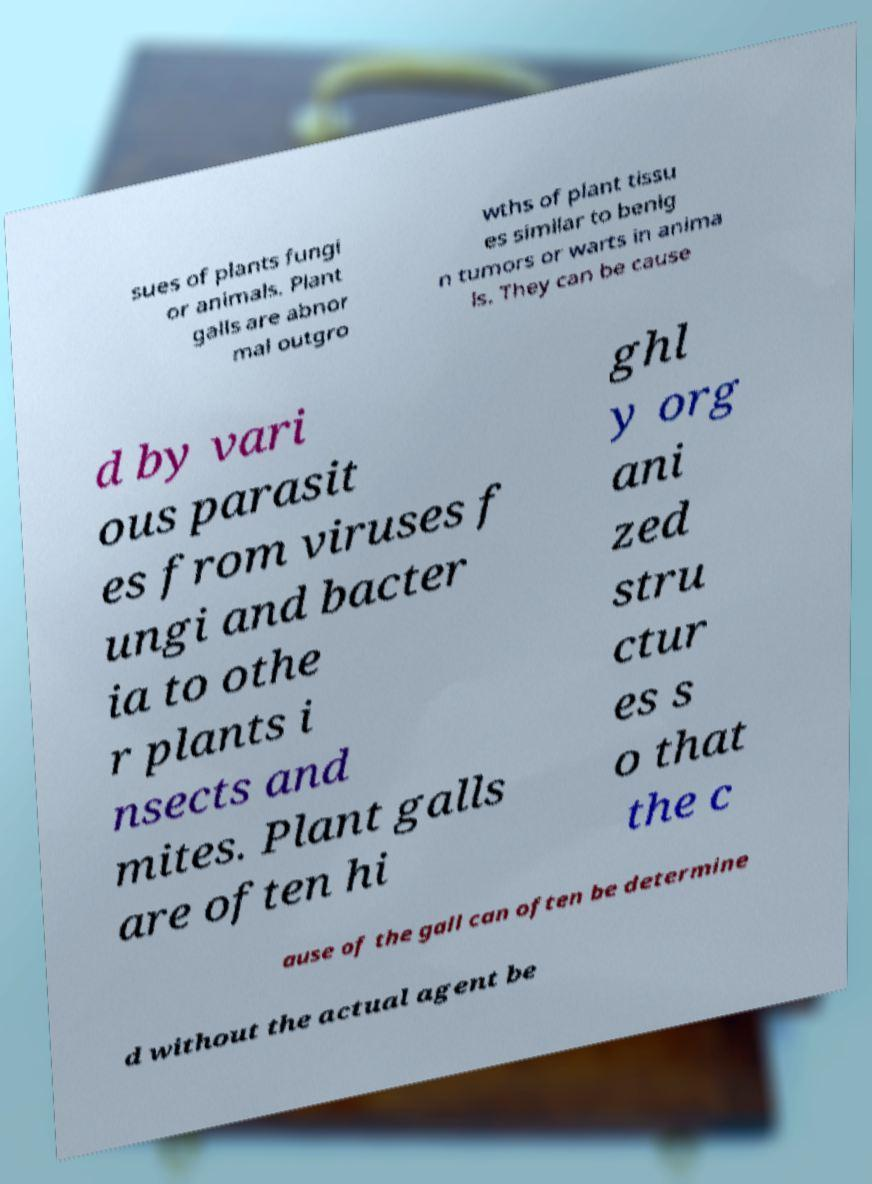Please read and relay the text visible in this image. What does it say? sues of plants fungi or animals. Plant galls are abnor mal outgro wths of plant tissu es similar to benig n tumors or warts in anima ls. They can be cause d by vari ous parasit es from viruses f ungi and bacter ia to othe r plants i nsects and mites. Plant galls are often hi ghl y org ani zed stru ctur es s o that the c ause of the gall can often be determine d without the actual agent be 